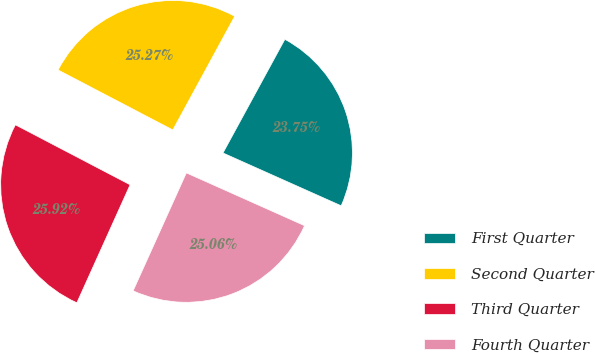<chart> <loc_0><loc_0><loc_500><loc_500><pie_chart><fcel>First Quarter<fcel>Second Quarter<fcel>Third Quarter<fcel>Fourth Quarter<nl><fcel>23.75%<fcel>25.27%<fcel>25.92%<fcel>25.06%<nl></chart> 